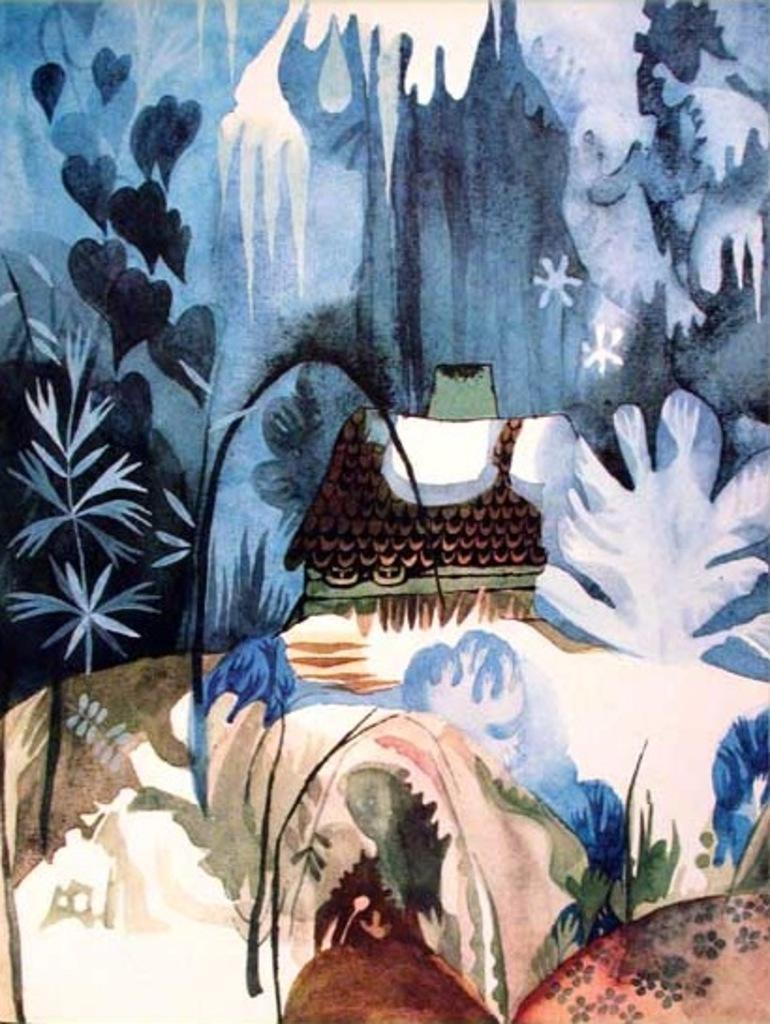What type of artwork is depicted in the image? The image is a painting. What is the main subject of the painting? There is a house in the picture. What can be seen in the background of the painting? There are plants and heart-shaped leaves in the background of the picture. What channel is the house located on in the image? The image is a painting, not a photograph or video, so there is no concept of a channel in this context. 